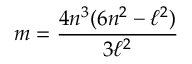<formula> <loc_0><loc_0><loc_500><loc_500>m = \frac { 4 n ^ { 3 } ( 6 n ^ { 2 } - \ell ^ { 2 } ) } { 3 \ell ^ { 2 } }</formula> 